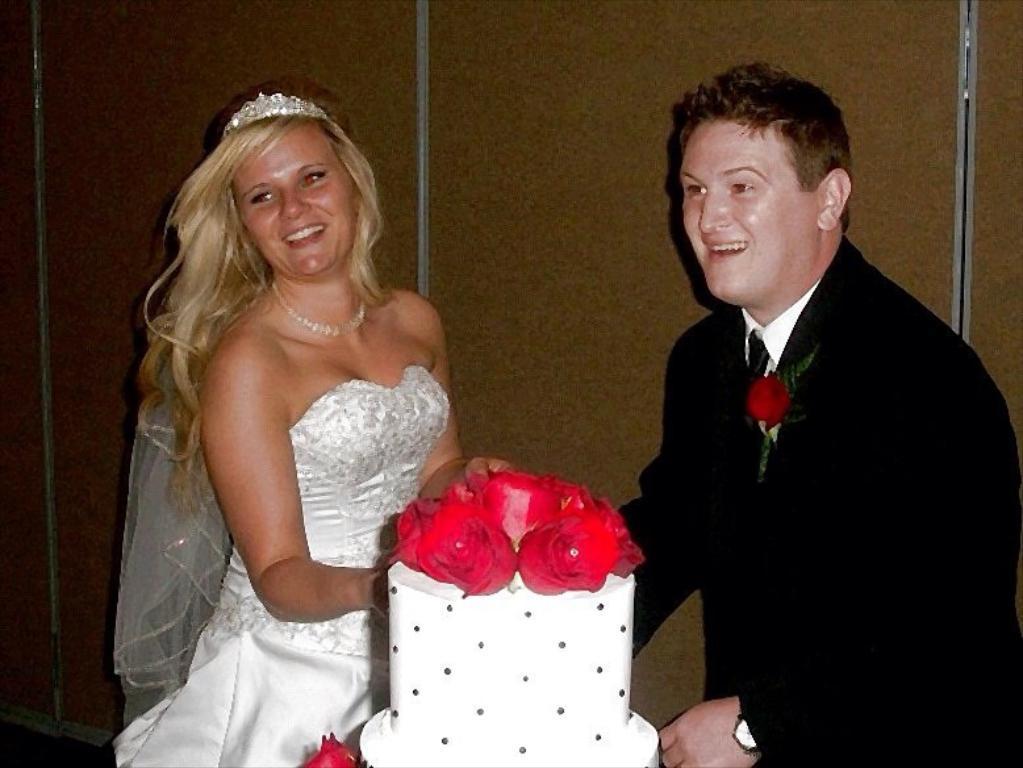How would you summarize this image in a sentence or two? In the center of the image there are couples standing. In front of them there is a cake. In the background of the image there is a wall. 